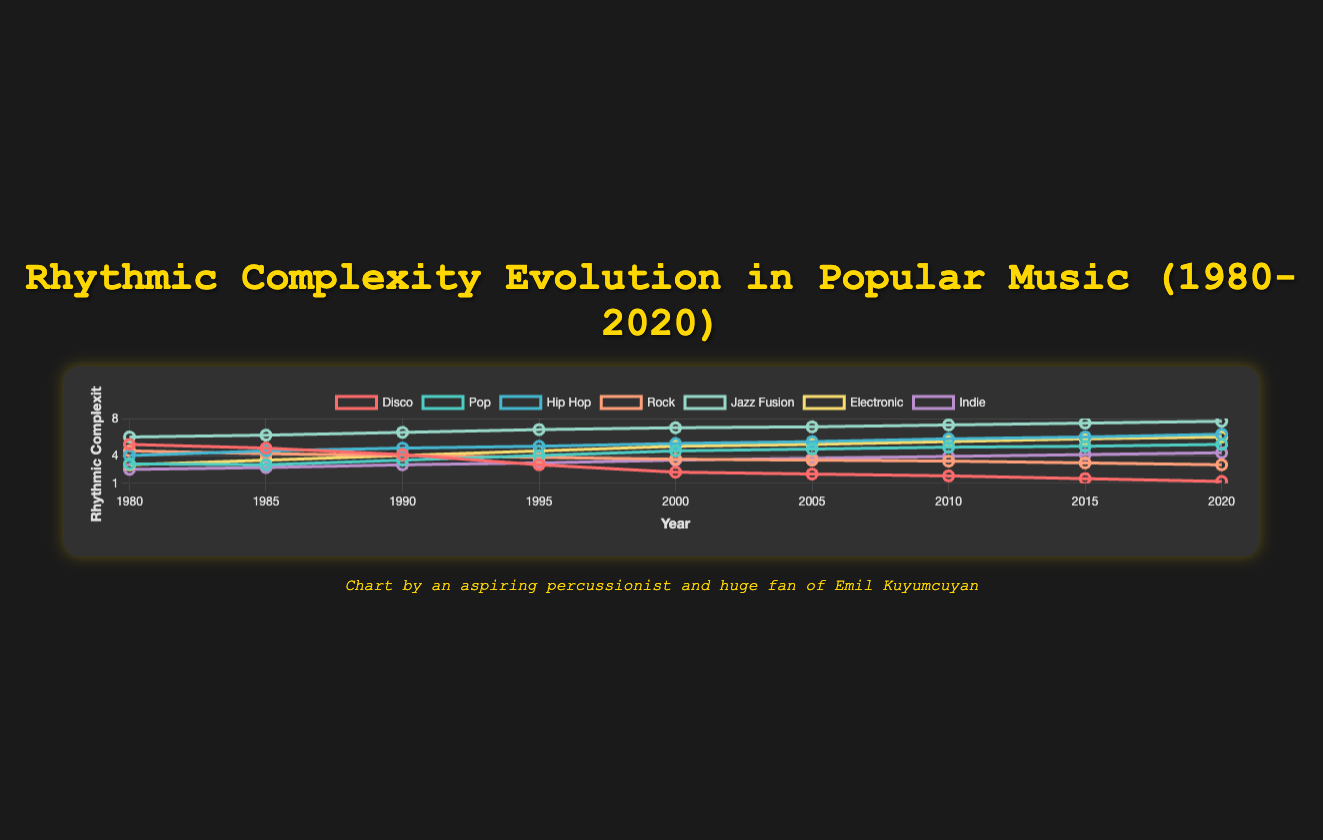Which genre shows the highest increase in rhythmic complexity from 1980 to 2020? By comparing the difference in rhythmic complexity for each genre from 1980 to 2020, we find that "Hip Hop" increased from 4.0 to 6.3, gaining 2.3, while "Jazz Fusion" increased from 6.0 to 7.7, gaining 1.7. The greatest increase is in "Hip Hop."
Answer: Hip Hop Which genre has the lowest rhythmic complexity in 2020? Looking at the values for 2020, "Disco" has the lowest rhythmic complexity of 1.2.
Answer: Disco In which year was the rhythmic complexity of Rock and Pop equal? By comparing the values across years, Rock (4.0) and Pop (4.0) had equal rhythmic complexity in 1995.
Answer: 1995 Compare the rhythmic complexity of Jazz Fusion and Indie in 2000. Which is higher and by how much? In 2000, Jazz Fusion is 7.0 and Indie is 3.5. The difference is 7.0 - 3.5 = 3.5. Jazz Fusion is higher by 3.5.
Answer: Jazz Fusion, by 3.5 What is the average rhythmic complexity of Disco in 1980 and 2020? The values are 5.2 in 1980 and 1.2 in 2020. The average is (5.2 + 1.2) / 2 = 3.2.
Answer: 3.2 Which genre had a decline in rhythmic complexity over the years and shows the largest decrease? By comparing the values from 1980 to 2020, Disco declined from 5.2 to 1.2, with a decrease of 4.0, which is the largest decline observed.
Answer: Disco What is the median rhythmic complexity of Pop over the years? Values for Pop are: [3.0, 3.1, 3.5, 4.0, 4.5, 4.7, 4.9, 5.0, 5.2]. The median is the middle value of the sorted list, which is 4.5.
Answer: 4.5 In which decade did Electronic music show the most significant increase in rhythmic complexity? The decades are: 1980-1990 (3.0 to 4.0: increase by 1.0), 1990-2000 (4.0 to 5.0: increase by 1.0), 2000-2010 (5.0 to 5.5: increase by 0.5), 2010-2020 (5.5 to 6.0: increase by 0.5). The most significant increase is in the 1990s.
Answer: 1990s Compare the rhythmic complexity of Pop and Hip Hop in 2010. Which is higher? In 2010, Pop has a value of 4.9 and Hip Hop has a value of 5.8. Hip Hop is higher.
Answer: Hip Hop Which genre showed a consistent increase in rhythmic complexity from 1980 to 2020? By examining each genre's trend, "Hip Hop," "Jazz Fusion," "Electronic," and "Indie" show a consistent increase. This is evident because their values continually rise without any decrease.
Answer: Hip Hop, Jazz Fusion, Electronic, Indie 